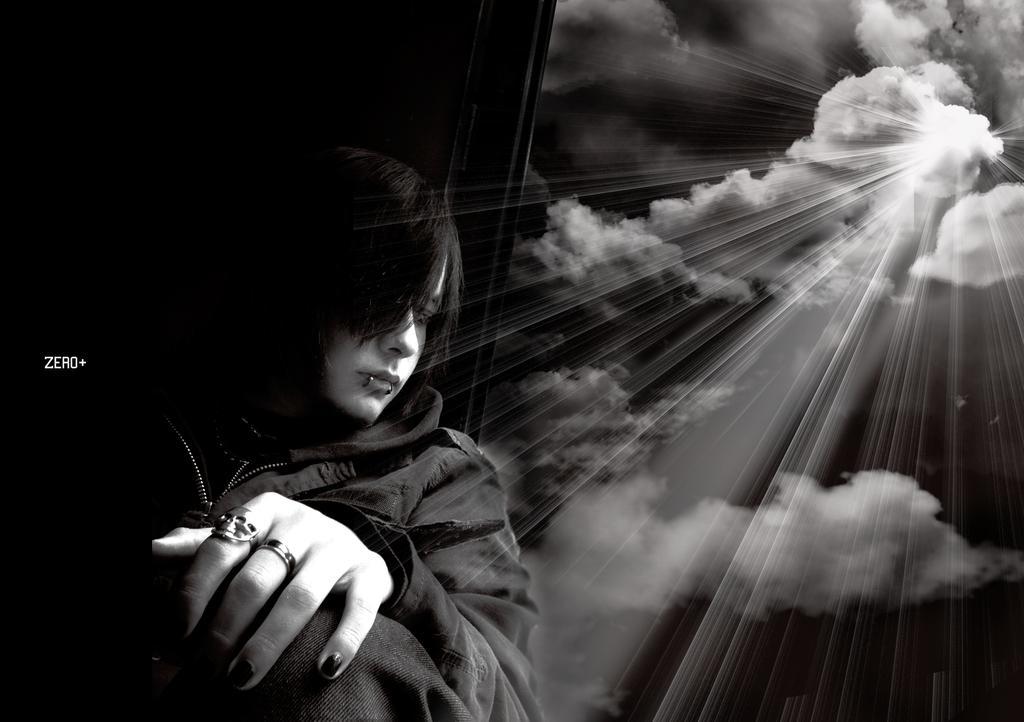How would you summarize this image in a sentence or two? This is the picture of a person in black dress and also we can see some clouds to the sky. 